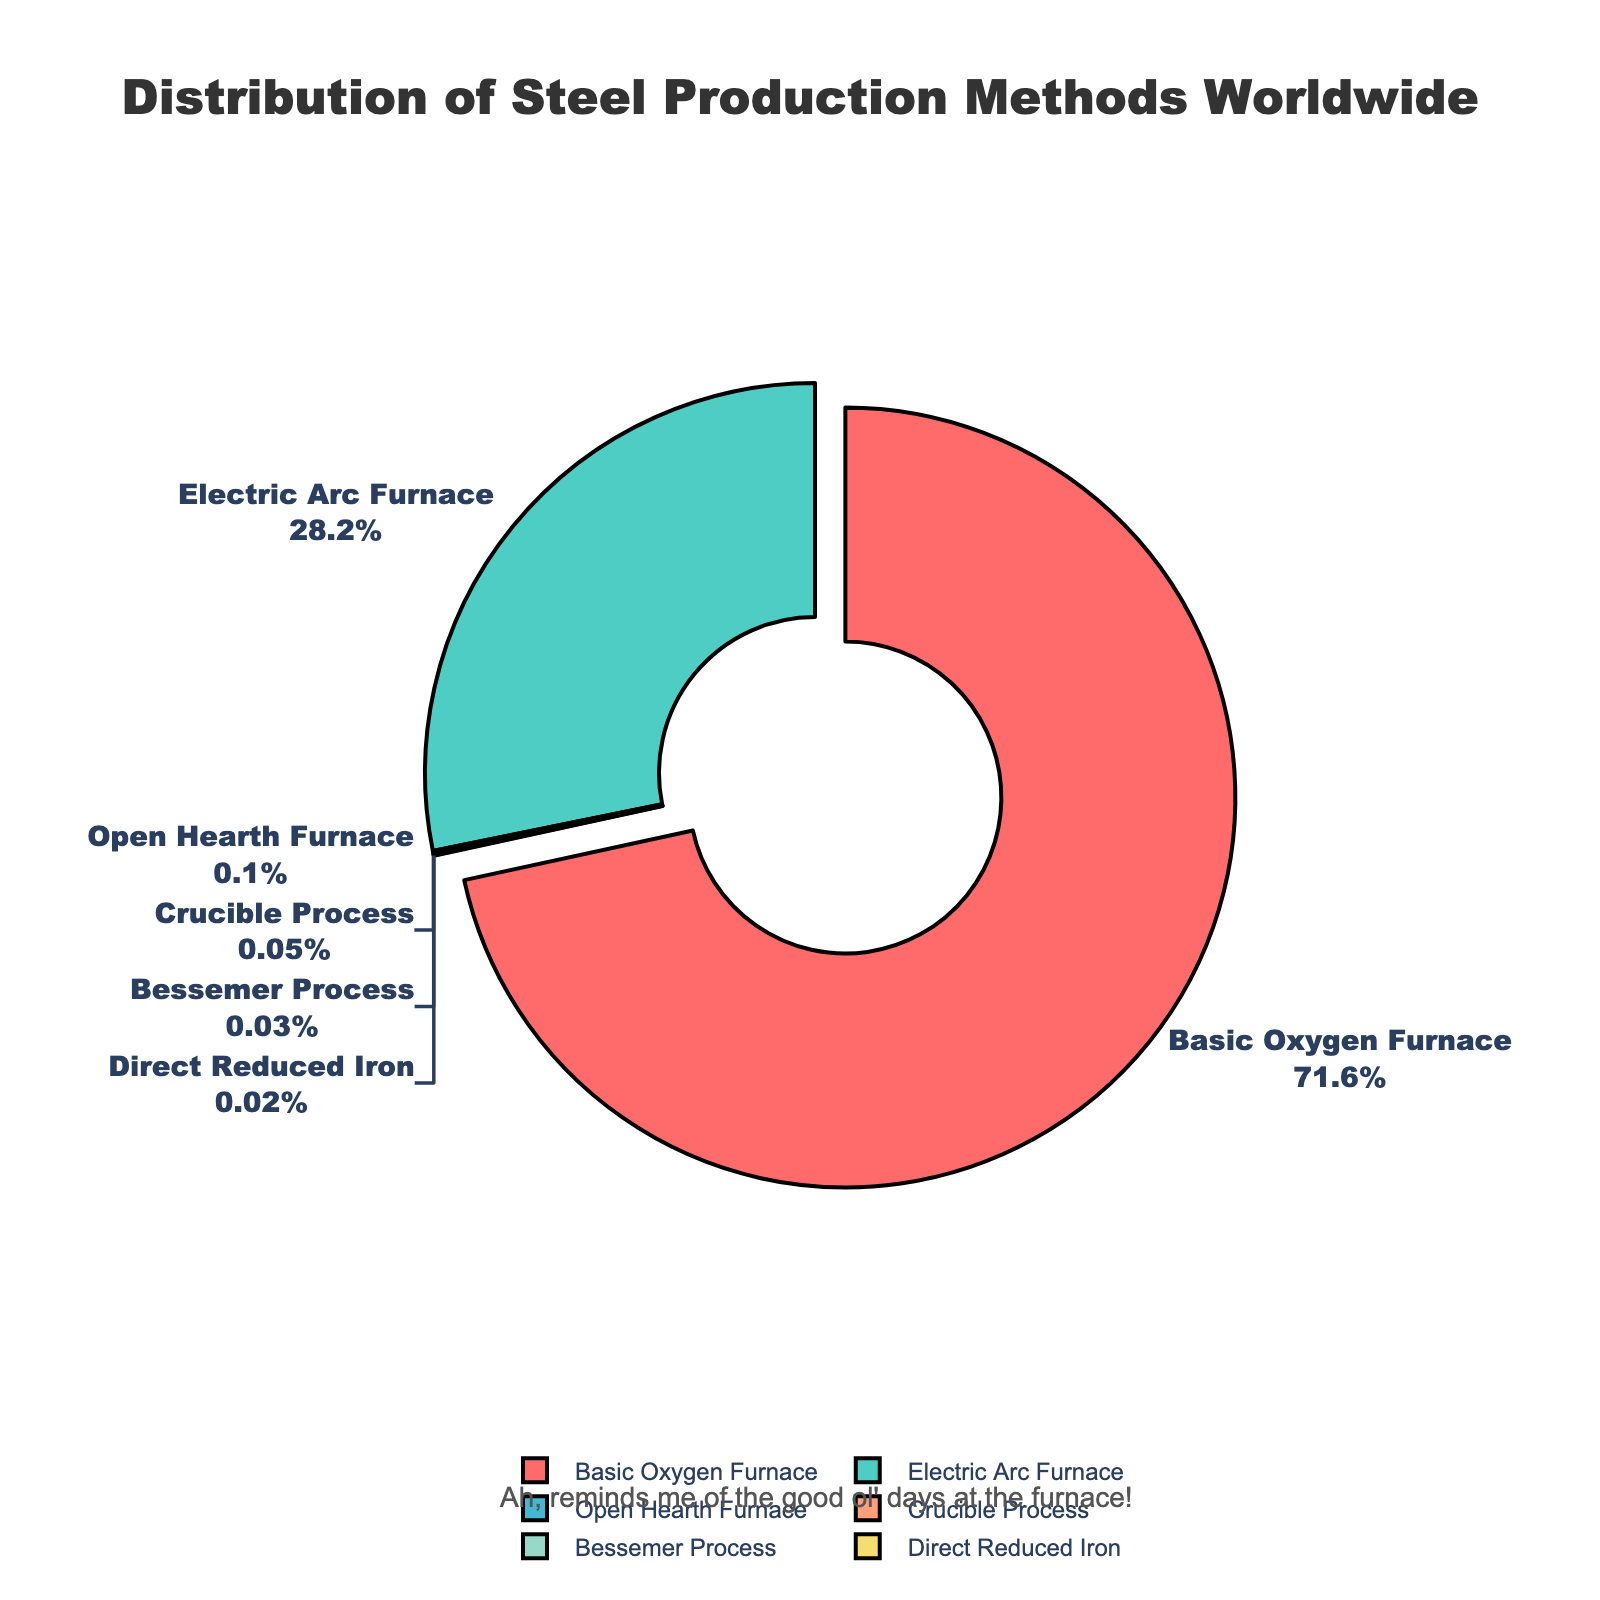Which steel production method has the highest percentage? The segment that stands out the most is "Basic Oxygen Furnace," which is also visually emphasized by being slightly pulled out from the pie chart. The percentage for this method is displayed as the largest.
Answer: Basic Oxygen Furnace What is the combined percentage of "Open Hearth Furnace," "Crucible Process," "Bessemer Process," and "Direct Reduced Iron"? To find the combined percentage, sum up the percentages of each method: 0.1% + 0.05% + 0.03% + 0.02%.
Answer: 0.2% How does the percentage of Electric Arc Furnace compare to that of the Basic Oxygen Furnace? The Electric Arc Furnace has a smaller percentage compared to the Basic Oxygen Furnace. The Basic Oxygen Furnace stands at 71.6%, while the Electric Arc Furnace is at 28.2%.
Answer: Electric Arc Furnace has a smaller percentage Which method's percentage is less than 0.1%? The percentages for "Crucible Process," "Bessemer Process," and "Direct Reduced Iron" are all less than 0.1%, as indicated by the figures shown on the chart.
Answer: Crucible Process, Bessemer Process, Direct Reduced Iron What is the percentage difference between the Basic Oxygen Furnace and Electric Arc Furnace? Subtract the percentage of Electric Arc Furnace (28.2%) from the percentage of Basic Oxygen Furnace (71.6%) to get the difference. 71.6% - 28.2% = 43.4%.
Answer: 43.4% Which segment is colored red and what is its percentage? The segment colored red corresponds to the "Basic Oxygen Furnace," which holds the largest percentage of 71.6%.
Answer: Basic Oxygen Furnace, 71.6% Sum the percentages of methods with less than 1% representation. Add the percentages of Open Hearth Furnace (0.1%), Crucible Process (0.05%), Bessemer Process (0.03%), and Direct Reduced Iron (0.02%): 0.1% + 0.05% + 0.03% + 0.02%.
Answer: 0.2% What visual attribute highlights the most common steel production method in the chart? The most common method, "Basic Oxygen Furnace," is visually highlighted by being pulled slightly out from the rest of the pie segments.
Answer: Highlighted by being pulled out How many production methods have a percentage of less than 1%? There are four methods with percentages less than 1%: "Open Hearth Furnace," "Crucible Process," "Bessemer Process," and "Direct Reduced Iron."
Answer: Four 